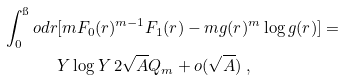<formula> <loc_0><loc_0><loc_500><loc_500>\int _ { 0 } ^ { \i } o d r & [ m F _ { 0 } ( r ) ^ { m - 1 } F _ { 1 } ( r ) - m g ( r ) ^ { m } \log g ( r ) ] = \\ & Y \log Y \, 2 \sqrt { A } Q _ { m } + o ( \sqrt { A } ) \ ,</formula> 